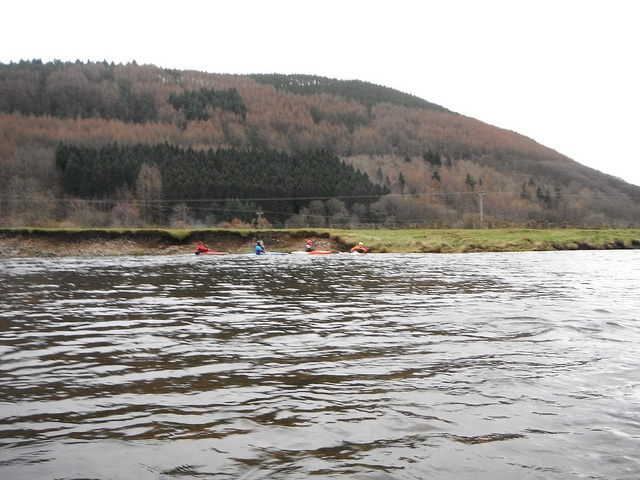Describe the objects in this image and their specific colors. I can see boat in white, maroon, tan, black, and ivory tones, boat in white, lightpink, salmon, and tan tones, boat in white, lightpink, gray, and maroon tones, people in white, darkgray, gray, navy, and lightblue tones, and people in white, maroon, and brown tones in this image. 